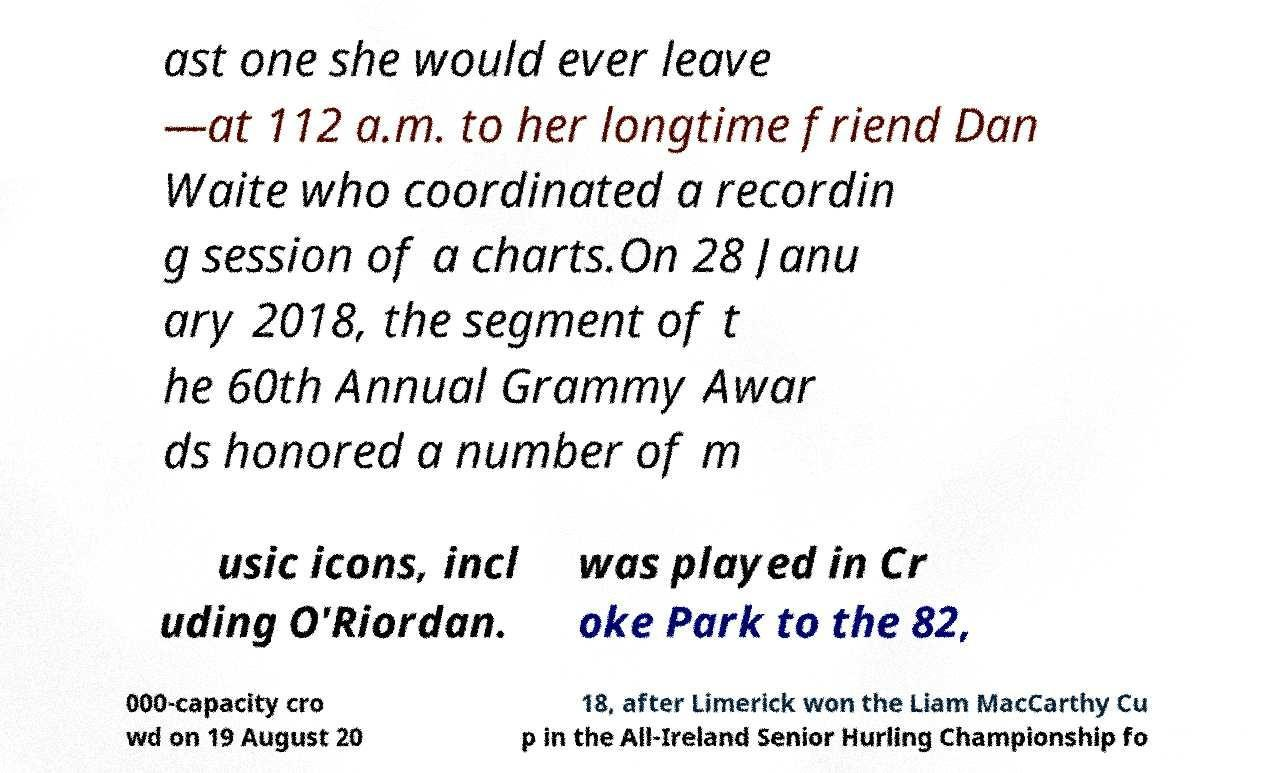Please identify and transcribe the text found in this image. ast one she would ever leave —at 112 a.m. to her longtime friend Dan Waite who coordinated a recordin g session of a charts.On 28 Janu ary 2018, the segment of t he 60th Annual Grammy Awar ds honored a number of m usic icons, incl uding O'Riordan. was played in Cr oke Park to the 82, 000-capacity cro wd on 19 August 20 18, after Limerick won the Liam MacCarthy Cu p in the All-Ireland Senior Hurling Championship fo 